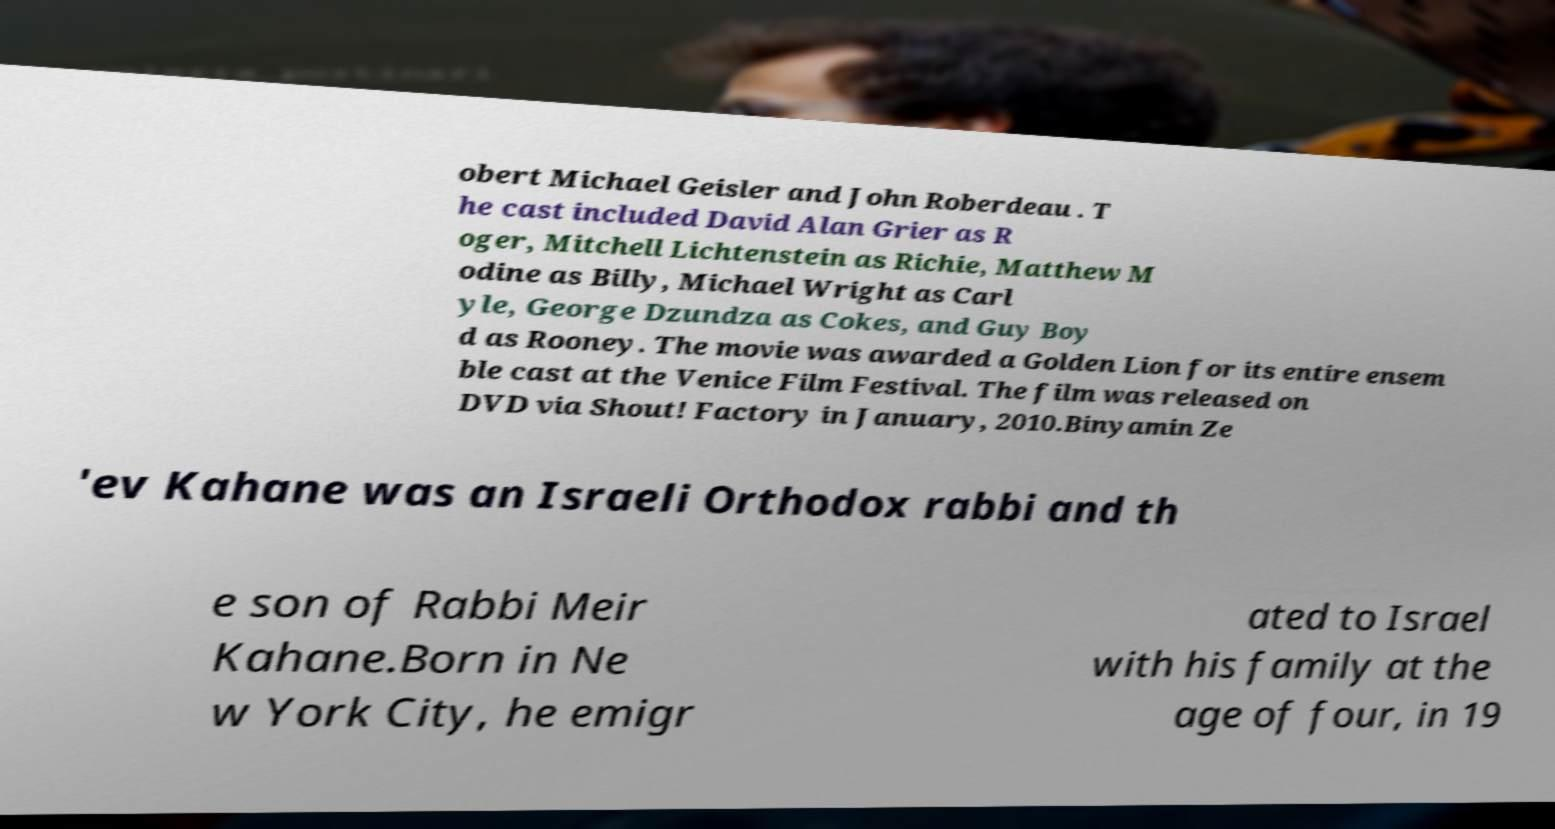Could you extract and type out the text from this image? obert Michael Geisler and John Roberdeau . T he cast included David Alan Grier as R oger, Mitchell Lichtenstein as Richie, Matthew M odine as Billy, Michael Wright as Carl yle, George Dzundza as Cokes, and Guy Boy d as Rooney. The movie was awarded a Golden Lion for its entire ensem ble cast at the Venice Film Festival. The film was released on DVD via Shout! Factory in January, 2010.Binyamin Ze 'ev Kahane was an Israeli Orthodox rabbi and th e son of Rabbi Meir Kahane.Born in Ne w York City, he emigr ated to Israel with his family at the age of four, in 19 